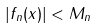Convert formula to latex. <formula><loc_0><loc_0><loc_500><loc_500>| f _ { n } ( x ) | < M _ { n }</formula> 